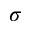<formula> <loc_0><loc_0><loc_500><loc_500>\sigma</formula> 